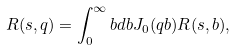<formula> <loc_0><loc_0><loc_500><loc_500>R ( s , q ) = \int _ { 0 } ^ { \infty } b d b J _ { 0 } ( q b ) R ( s , b ) ,</formula> 